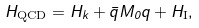<formula> <loc_0><loc_0><loc_500><loc_500>H _ { \text {QCD} } = H _ { k } + \bar { q } M _ { 0 } q + H _ { \text {I} } ,</formula> 